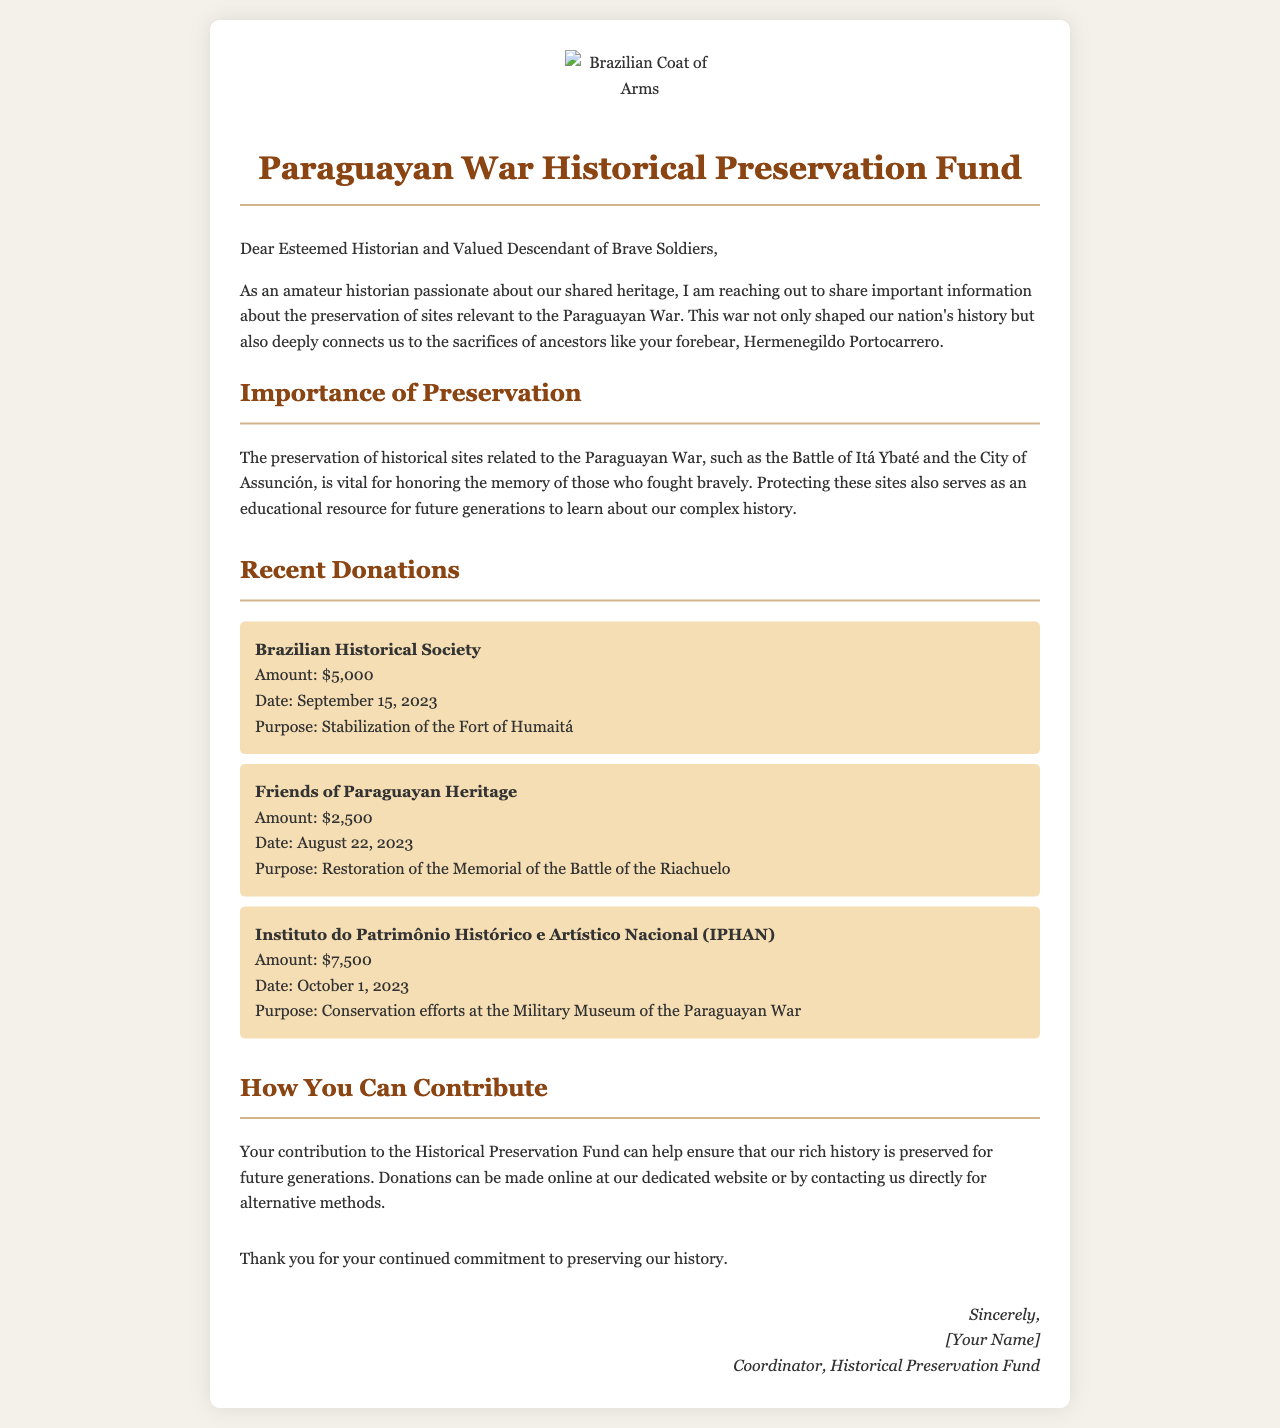what is the title of the document? The title is prominently displayed at the top of the document, indicating its purpose.
Answer: Paraguayan War Historical Preservation Fund what is the date of the first recorded donation? The first donation listed is from a specific date, found in the Recent Donations section.
Answer: September 15, 2023 who made the donation for the stabilization of the Fort of Humaitá? This information can be found in the list of donations, connecting the organization to its specific purpose.
Answer: Brazilian Historical Society how much did the Instituto do Patrimônio Histórico e Artístico Nacional donate? The amount donated by this organization is clearly stated in the Recent Donations section.
Answer: $7,500 what is the purpose of the donation from Friends of Paraguayan Heritage? The document specifies the goal of this particular donation within the donation details.
Answer: Restoration of the Memorial of the Battle of the Riachuelo who is the coordinator of the Historical Preservation Fund? The signature line at the end of the document indicates the name of the coordinator.
Answer: [Your Name] how can individuals contribute to the Historical Preservation Fund? The document provides a brief description of the methods for making contributions.
Answer: Online at our dedicated website what sites are mentioned as relevant to the Paraguayan War? The document mentions specific locations that hold historical significance in relation to the war.
Answer: Battle of Itá Ybaté and the City of Assunción 